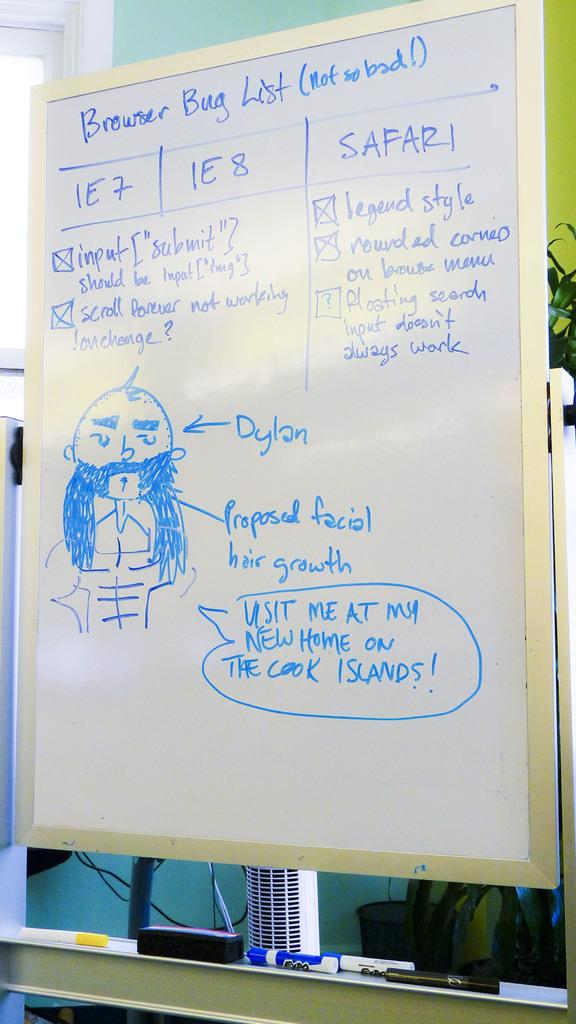<image>
Provide a brief description of the given image. Someone has drawn a cartoon of Dylan on the whiteboard. 